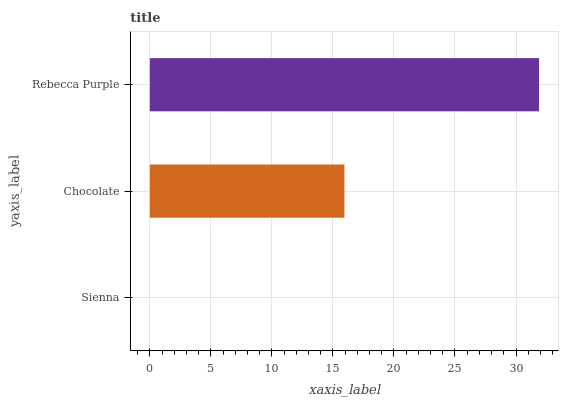Is Sienna the minimum?
Answer yes or no. Yes. Is Rebecca Purple the maximum?
Answer yes or no. Yes. Is Chocolate the minimum?
Answer yes or no. No. Is Chocolate the maximum?
Answer yes or no. No. Is Chocolate greater than Sienna?
Answer yes or no. Yes. Is Sienna less than Chocolate?
Answer yes or no. Yes. Is Sienna greater than Chocolate?
Answer yes or no. No. Is Chocolate less than Sienna?
Answer yes or no. No. Is Chocolate the high median?
Answer yes or no. Yes. Is Chocolate the low median?
Answer yes or no. Yes. Is Rebecca Purple the high median?
Answer yes or no. No. Is Sienna the low median?
Answer yes or no. No. 